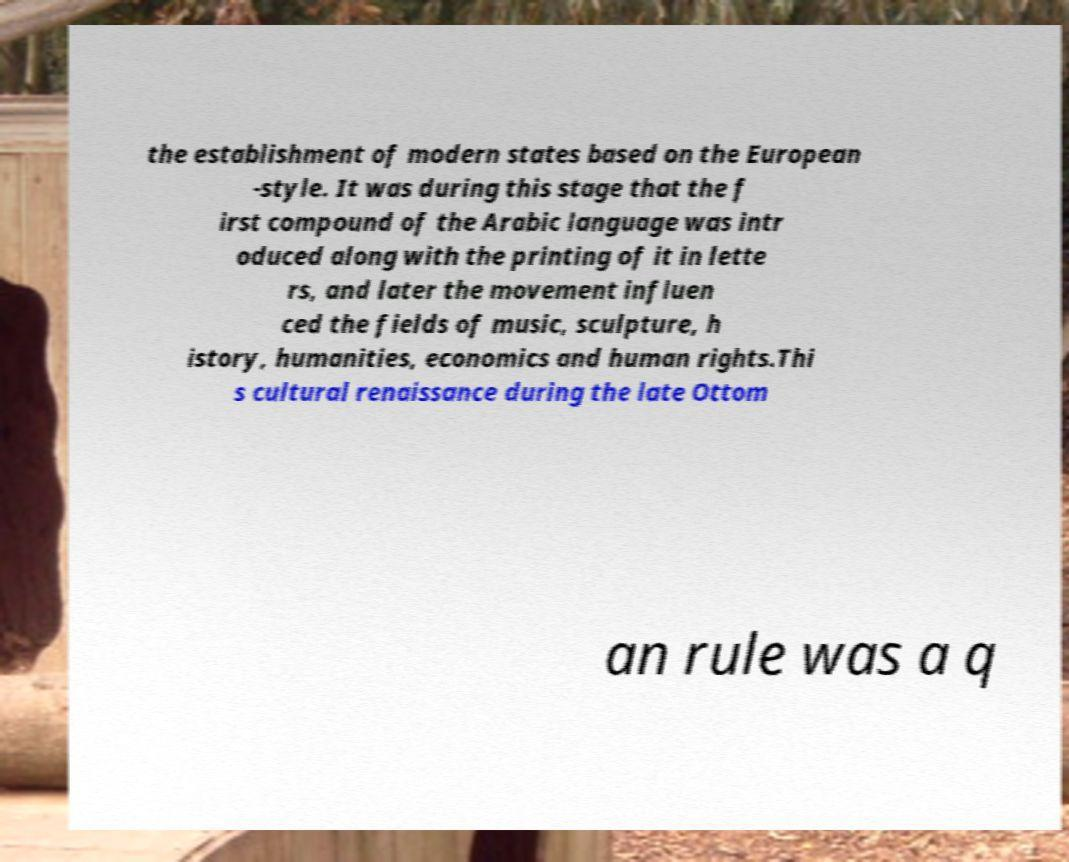What messages or text are displayed in this image? I need them in a readable, typed format. the establishment of modern states based on the European -style. It was during this stage that the f irst compound of the Arabic language was intr oduced along with the printing of it in lette rs, and later the movement influen ced the fields of music, sculpture, h istory, humanities, economics and human rights.Thi s cultural renaissance during the late Ottom an rule was a q 